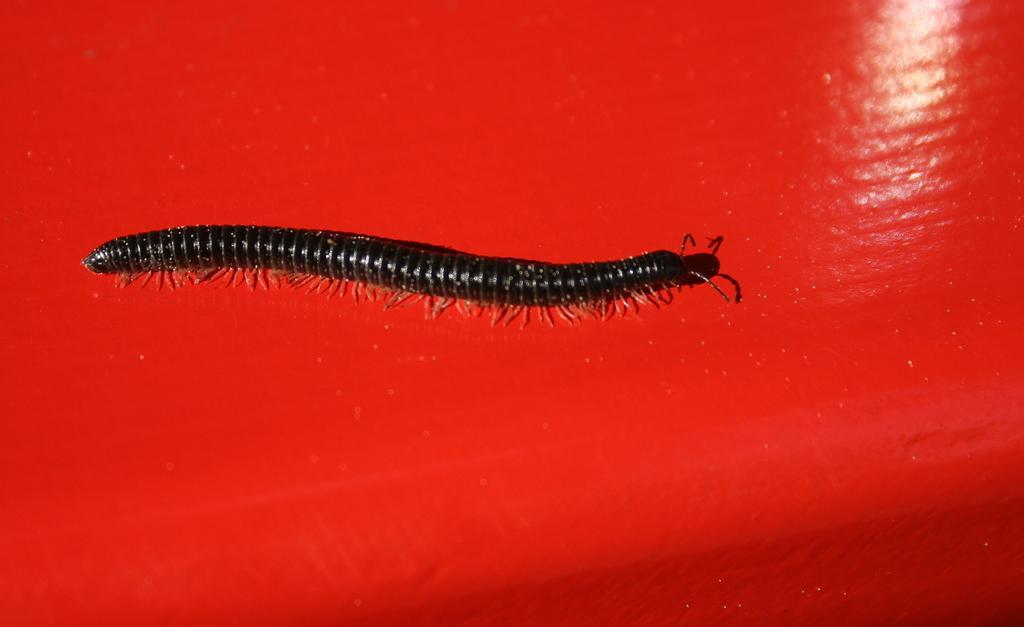How would you summarize this image in a sentence or two? In the center of the image we can see a worm on the table. 